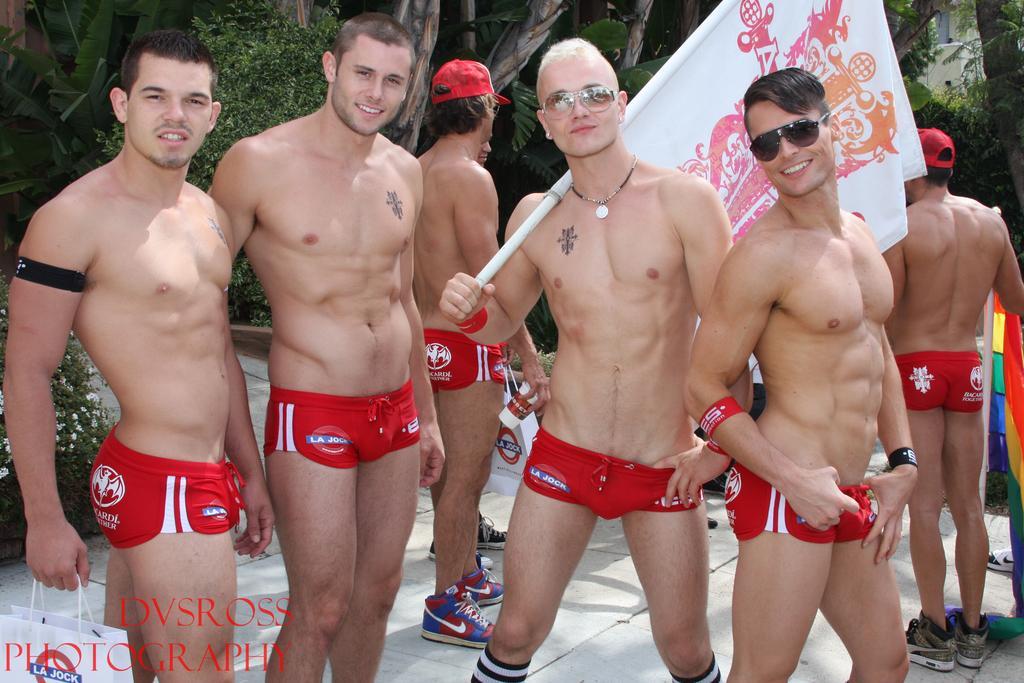Please provide a concise description of this image. In this image we can see these men are standing on the floor, we can see this person holding a bag, this person holding a flag. In the background, we can see trees, here we can see the watermark on the bottom left side of the image. 